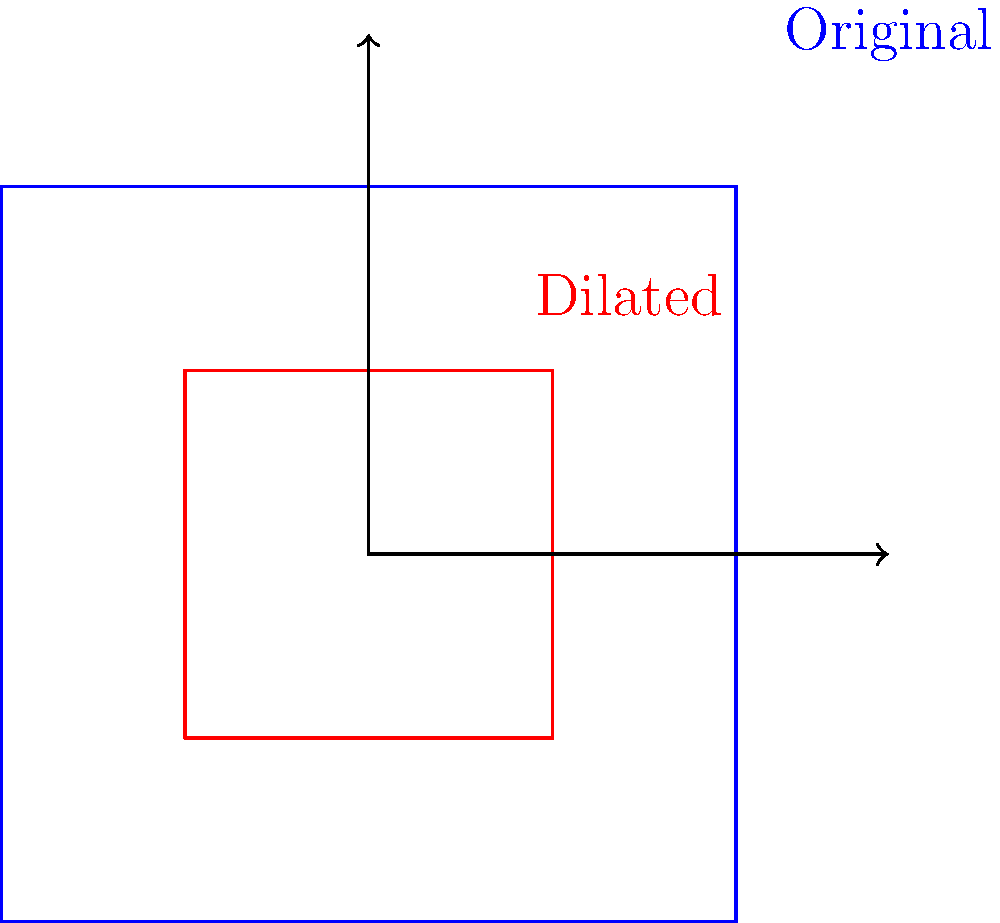During a stadium renovation project, you're tasked with creating a scaled-down version of the football stadium seating chart for a presentation. If the original seating chart has dimensions of 20 feet by 20 feet and you need to fit it on a board that's 10 feet by 10 feet, what scale factor should you use for the dilation? How would this affect the area of the seating chart? To solve this problem, let's follow these steps:

1. Determine the scale factor:
   - Original dimensions: 20 feet × 20 feet
   - New dimensions: 10 feet × 10 feet
   - Scale factor = New dimension ÷ Original dimension
   - Scale factor = 10 ÷ 20 = 0.5 or 1/2

2. Verify the scale factor:
   - New width = Original width × Scale factor
   - 10 = 20 × 0.5
   - New height = Original height × Scale factor
   - 10 = 20 × 0.5

3. Effect on area:
   - Original area = 20 × 20 = 400 sq ft
   - New area = 10 × 10 = 100 sq ft
   - Area scale factor = (0.5)² = 0.25 or 1/4

   The area of the new seating chart will be 1/4 of the original area.

4. Algebraic representation:
   - If we denote the scale factor as $k$, then for any shape:
     - New length = $k$ × Original length
     - New area = $k²$ × Original area

In this case, $k = 0.5$, so the new area is $(0.5)² = 0.25$ times the original area.
Answer: Scale factor: 0.5; Area reduced to 1/4 of original 